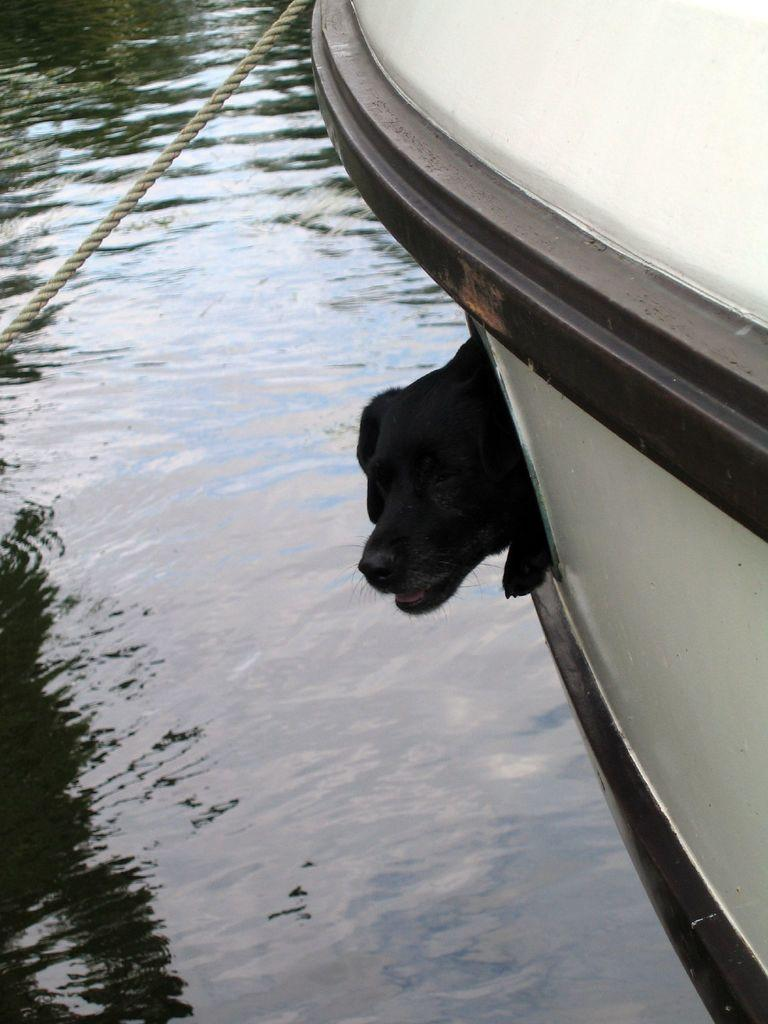What is the main subject of the image? The main subject of the image is an object that looks like a watercraft. What can be seen inside the watercraft? There is a dog inside the object. What is visible on the left side of the image? Water is visible on the left side of the image. Can you describe the rope in the image? Yes, there is a rope in the top left of the image. What type of soup is being prepared by the laborer in the image? There is no laborer or soup present in the image. How does the hook attached to the watercraft help in the image? There is no hook attached to the watercraft in the image. 